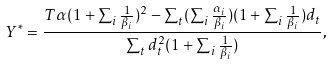Convert formula to latex. <formula><loc_0><loc_0><loc_500><loc_500>Y ^ { * } = \frac { T \alpha ( 1 + \sum _ { i } \frac { 1 } { \beta _ { i } } ) ^ { 2 } - \sum _ { t } ( \sum _ { i } \frac { \alpha _ { i } } { \beta _ { i } } ) ( 1 + \sum _ { i } \frac { 1 } { \beta _ { i } } ) d _ { t } } { \sum _ { t } d _ { t } ^ { 2 } ( 1 + \sum _ { i } \frac { 1 } { \beta _ { i } } ) } ,</formula> 